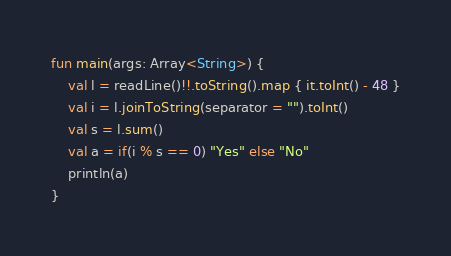Convert code to text. <code><loc_0><loc_0><loc_500><loc_500><_Kotlin_>fun main(args: Array<String>) {
    val l = readLine()!!.toString().map { it.toInt() - 48 }
    val i = l.joinToString(separator = "").toInt()
    val s = l.sum()
    val a = if(i % s == 0) "Yes" else "No"
    println(a)
}</code> 